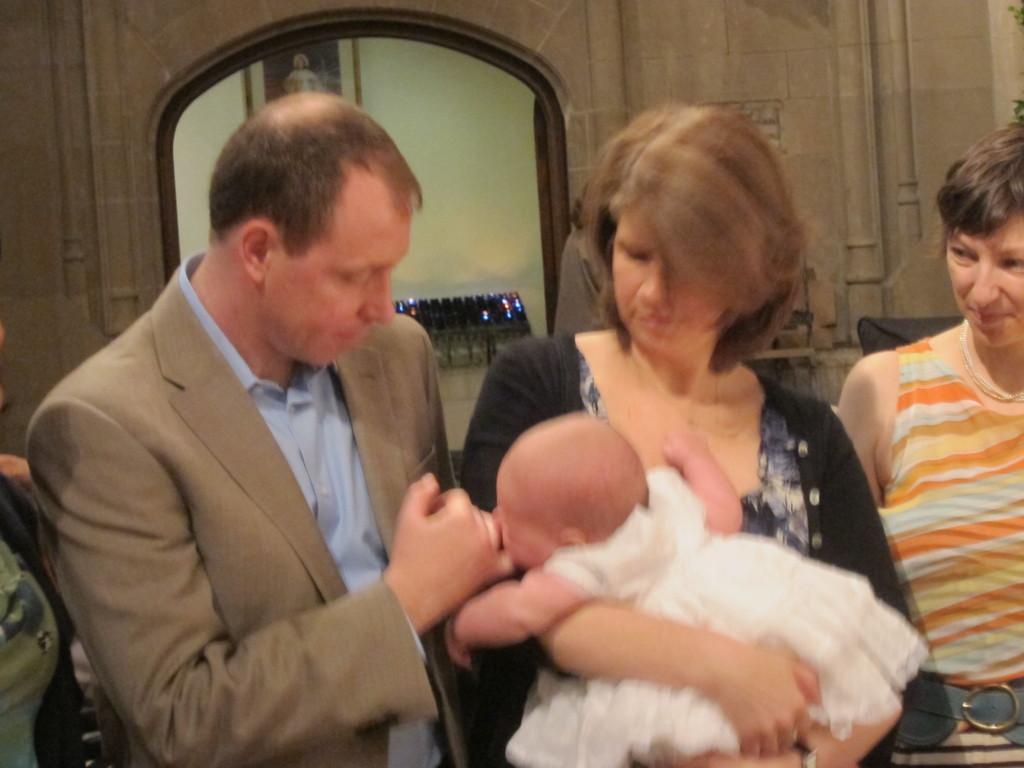Can you describe this image briefly? In front of the image there is a woman holding a toddler in her arms, besides the woman there is a man and a woman standing, behind them there are some objects. In the background of the image there is a photo frame on the wall. Beside the man there are some objects. 